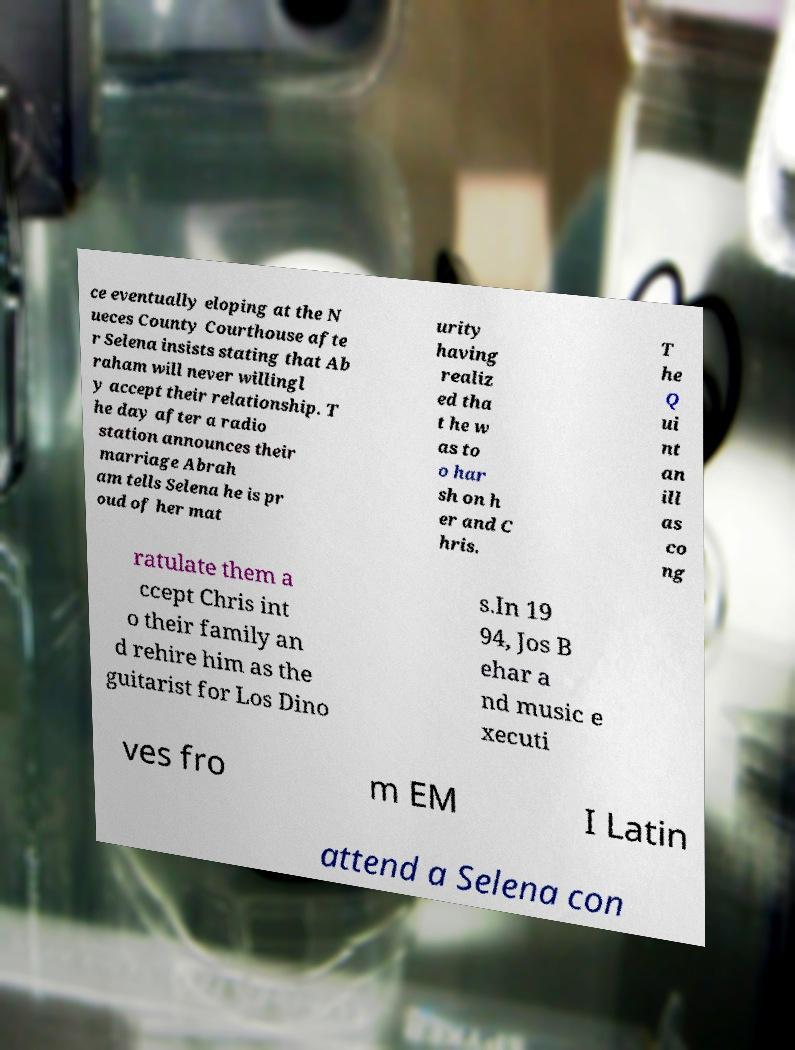Could you assist in decoding the text presented in this image and type it out clearly? ce eventually eloping at the N ueces County Courthouse afte r Selena insists stating that Ab raham will never willingl y accept their relationship. T he day after a radio station announces their marriage Abrah am tells Selena he is pr oud of her mat urity having realiz ed tha t he w as to o har sh on h er and C hris. T he Q ui nt an ill as co ng ratulate them a ccept Chris int o their family an d rehire him as the guitarist for Los Dino s.In 19 94, Jos B ehar a nd music e xecuti ves fro m EM I Latin attend a Selena con 